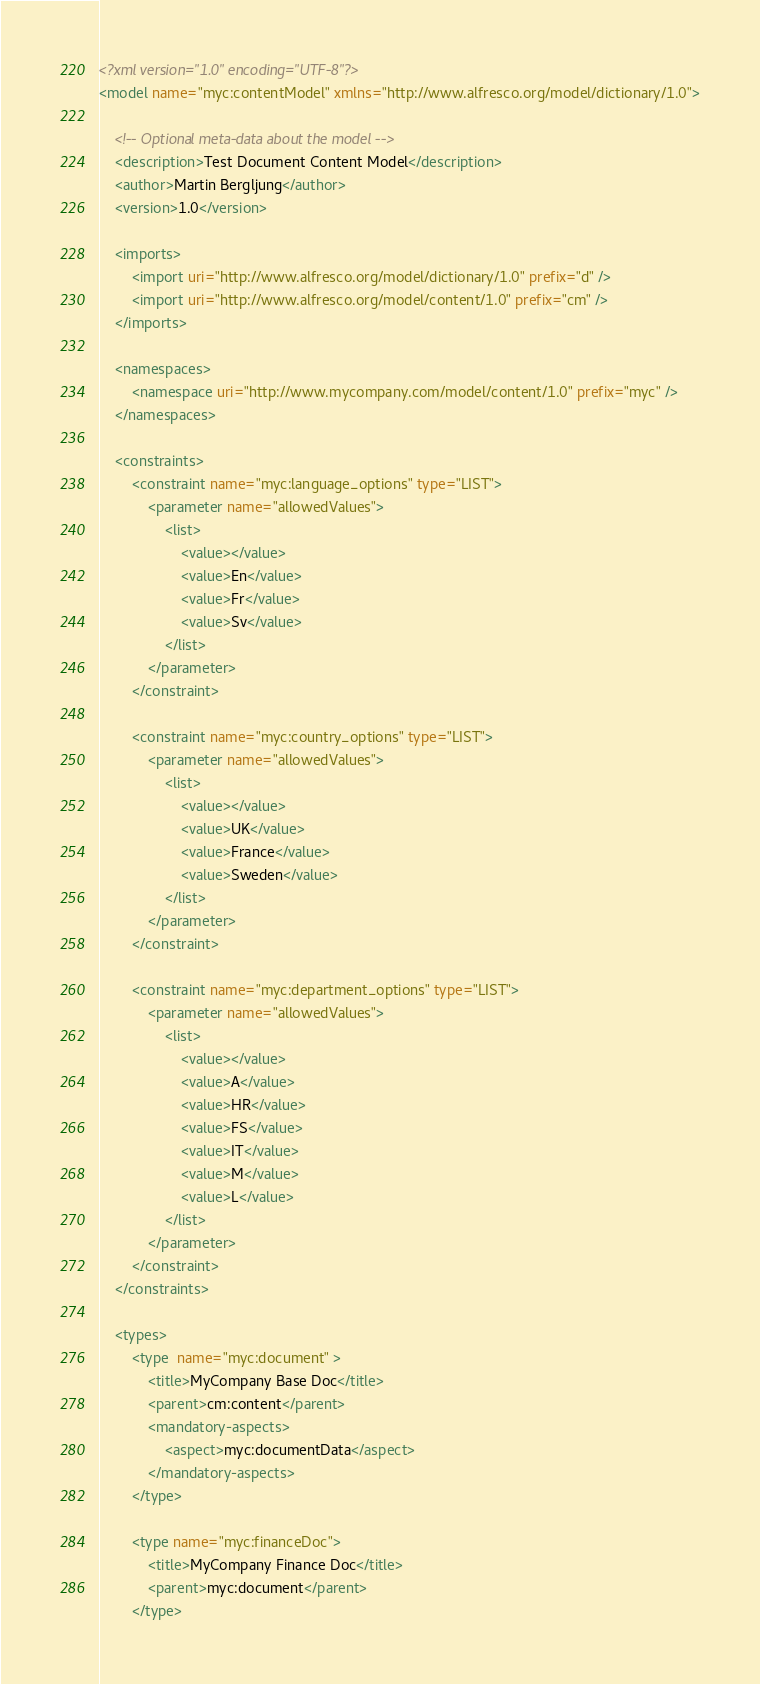Convert code to text. <code><loc_0><loc_0><loc_500><loc_500><_XML_><?xml version="1.0" encoding="UTF-8"?>
<model name="myc:contentModel" xmlns="http://www.alfresco.org/model/dictionary/1.0">

    <!-- Optional meta-data about the model -->
    <description>Test Document Content Model</description>
    <author>Martin Bergljung</author>
    <version>1.0</version>

    <imports>
        <import uri="http://www.alfresco.org/model/dictionary/1.0" prefix="d" />
        <import uri="http://www.alfresco.org/model/content/1.0" prefix="cm" />
    </imports>

    <namespaces>
        <namespace uri="http://www.mycompany.com/model/content/1.0" prefix="myc" />
    </namespaces>

    <constraints>
        <constraint name="myc:language_options" type="LIST">
            <parameter name="allowedValues">
                <list>
                    <value></value>
                    <value>En</value>
                    <value>Fr</value>
                    <value>Sv</value>
                </list>
            </parameter>
        </constraint>

        <constraint name="myc:country_options" type="LIST">
            <parameter name="allowedValues">
                <list>
                    <value></value>
                    <value>UK</value>
                    <value>France</value>
                    <value>Sweden</value>
                </list>
            </parameter>
        </constraint>

        <constraint name="myc:department_options" type="LIST">
            <parameter name="allowedValues">
                <list>
                    <value></value>
                    <value>A</value>
                    <value>HR</value>
                    <value>FS</value>
                    <value>IT</value>
                    <value>M</value>
                    <value>L</value>
                </list>
            </parameter>
        </constraint>
    </constraints>

    <types>
        <type  name="myc:document" >
            <title>MyCompany Base Doc</title>
            <parent>cm:content</parent>
            <mandatory-aspects>
                <aspect>myc:documentData</aspect>
            </mandatory-aspects>
        </type>

        <type name="myc:financeDoc">
            <title>MyCompany Finance Doc</title>
            <parent>myc:document</parent>
        </type>
</code> 